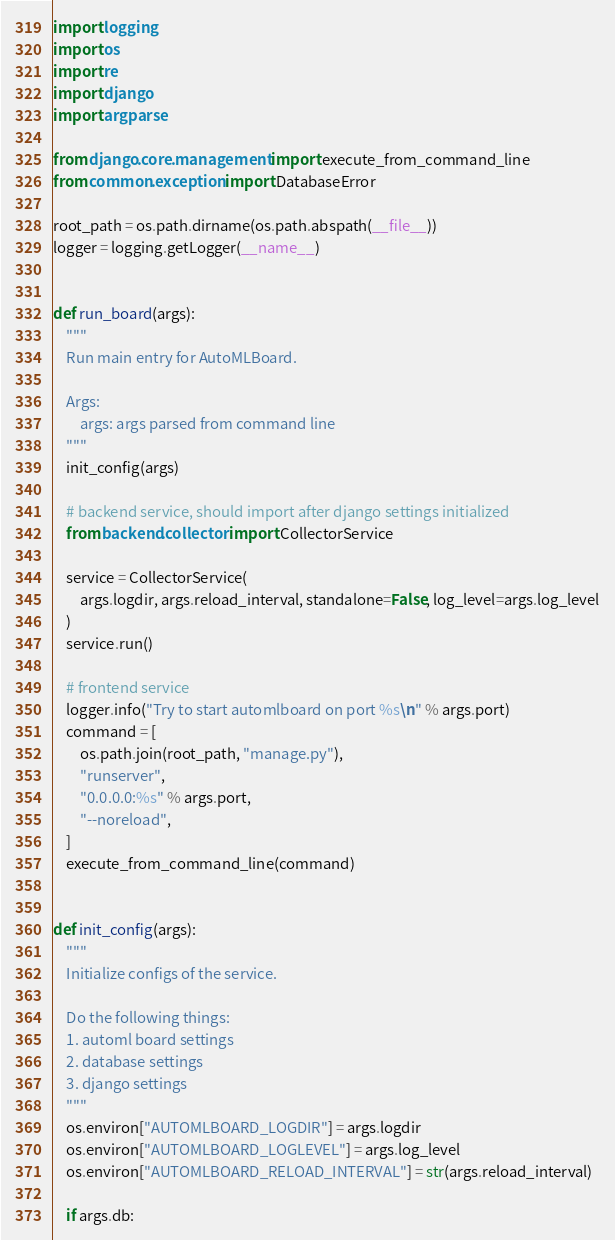Convert code to text. <code><loc_0><loc_0><loc_500><loc_500><_Python_>import logging
import os
import re
import django
import argparse

from django.core.management import execute_from_command_line
from common.exception import DatabaseError

root_path = os.path.dirname(os.path.abspath(__file__))
logger = logging.getLogger(__name__)


def run_board(args):
    """
    Run main entry for AutoMLBoard.

    Args:
        args: args parsed from command line
    """
    init_config(args)

    # backend service, should import after django settings initialized
    from backend.collector import CollectorService

    service = CollectorService(
        args.logdir, args.reload_interval, standalone=False, log_level=args.log_level
    )
    service.run()

    # frontend service
    logger.info("Try to start automlboard on port %s\n" % args.port)
    command = [
        os.path.join(root_path, "manage.py"),
        "runserver",
        "0.0.0.0:%s" % args.port,
        "--noreload",
    ]
    execute_from_command_line(command)


def init_config(args):
    """
    Initialize configs of the service.

    Do the following things:
    1. automl board settings
    2. database settings
    3. django settings
    """
    os.environ["AUTOMLBOARD_LOGDIR"] = args.logdir
    os.environ["AUTOMLBOARD_LOGLEVEL"] = args.log_level
    os.environ["AUTOMLBOARD_RELOAD_INTERVAL"] = str(args.reload_interval)

    if args.db:</code> 